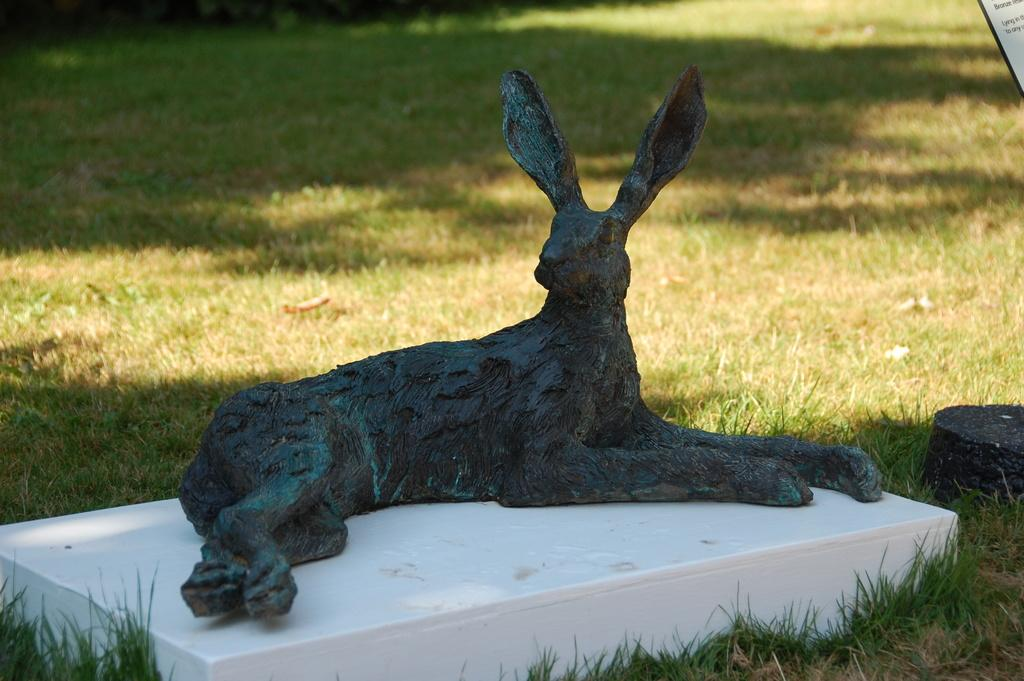What type of object is depicted in the image? There is a sculpture of an animal in the image. Where is the sculpture located? The sculpture is on the floor. What can be seen on the ground around the sculpture? There is grass on the ground around the sculpture. What type of cord is connected to the animal sculpture in the image? There is no cord connected to the animal sculpture in the image. 